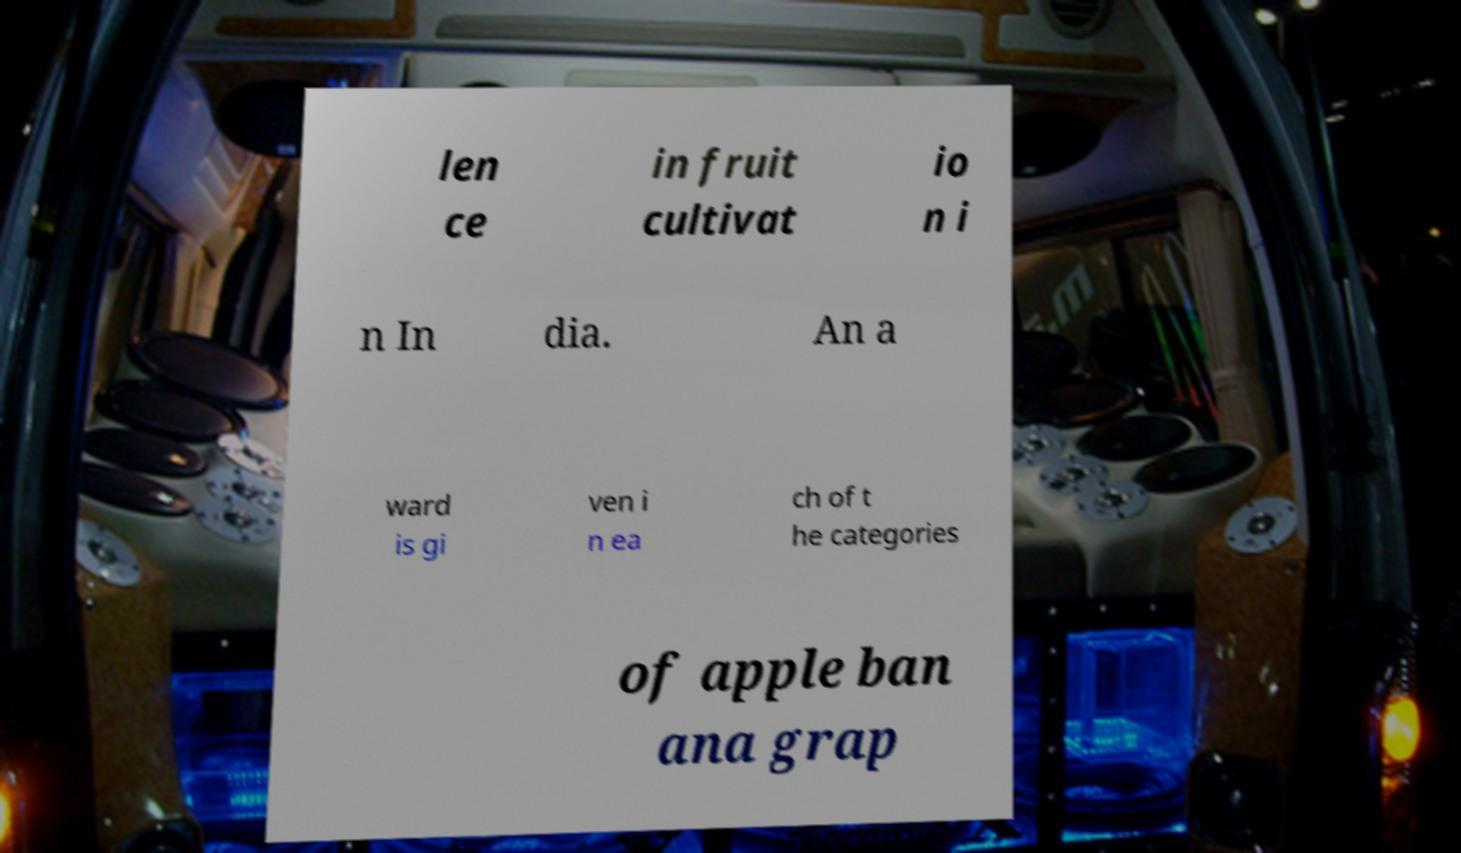Please read and relay the text visible in this image. What does it say? len ce in fruit cultivat io n i n In dia. An a ward is gi ven i n ea ch of t he categories of apple ban ana grap 